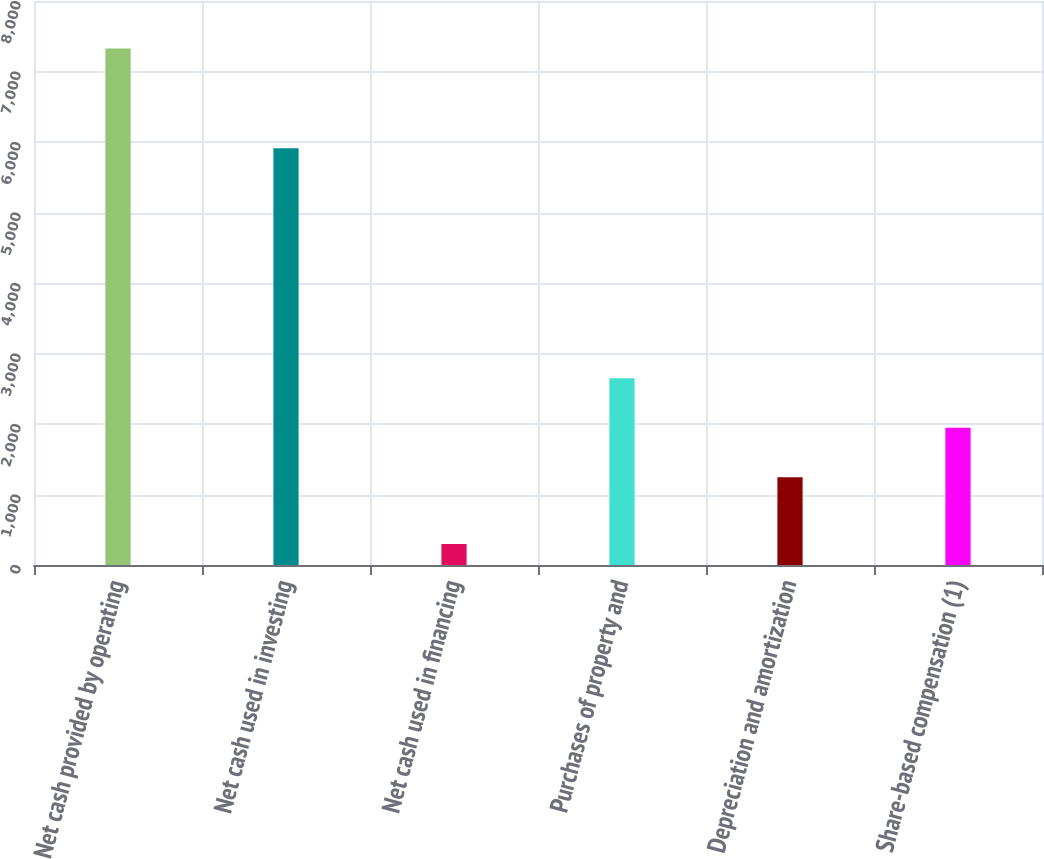<chart> <loc_0><loc_0><loc_500><loc_500><bar_chart><fcel>Net cash provided by operating<fcel>Net cash used in investing<fcel>Net cash used in financing<fcel>Purchases of property and<fcel>Depreciation and amortization<fcel>Share-based compensation (1)<nl><fcel>7326<fcel>5913<fcel>298<fcel>2648.6<fcel>1243<fcel>1945.8<nl></chart> 